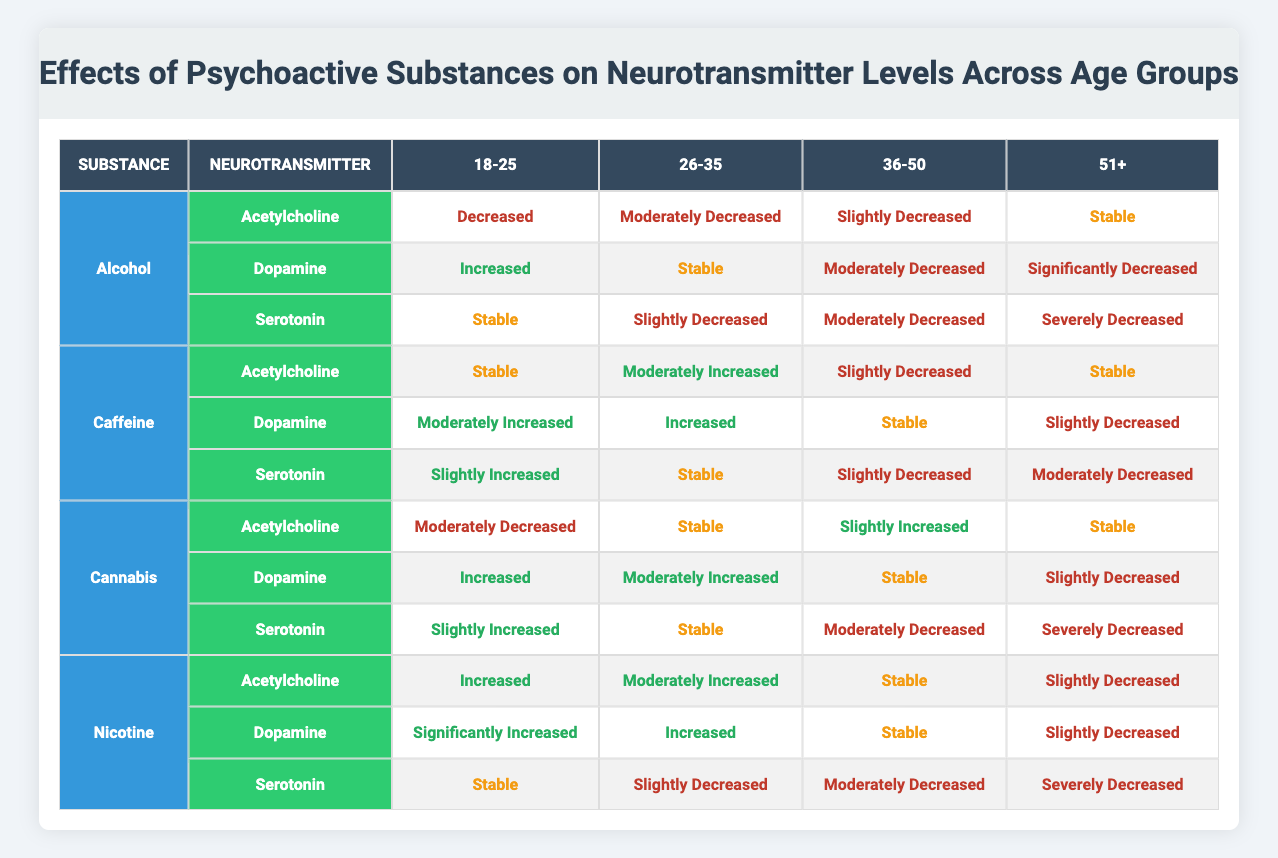What is the effect of Alcohol on Serotonin levels in the age group 36-50? According to the table, for Alcohol, the effect on Serotonin levels in the age group 36-50 is "Moderately Decreased." This can be found by looking at the row for Serotonin under Alcohol and then checking the value under the 36-50 age column.
Answer: Moderately Decreased Which psychoactive substance shows a "Stable" effect on Acetylcholine in individuals aged 51 and older? By scanning the table, the substances that show "Stable" effects on Acetylcholine for the age group 51+ are Alcohol and Caffeine. Both substances have the same effect listed under the specified age group.
Answer: Alcohol, Caffeine Do Caffeine's effects on Dopamine levels increase with age? Analyzing the table for Caffeine's effect on Dopamine levels across different age groups shows: Moderately Increased (18-25), Increased (26-35), Stable (36-50), and Slightly Decreased (51+). The trend does not indicate a consistent increase as age progresses, rather it fluctuates.
Answer: No What is the difference in effect on Serotonin between Cannabis and Alcohol for individuals aged 51 and older? First, find the Serotonin effect for Cannabis in the 51+ age group, which is "Severely Decreased." Then find the same for Alcohol, which is "Severely Decreased" as well. Since both effects are the same, there is no difference.
Answer: No difference Which neurotransmitter is significantly increased by Nicotine in the 18-25 age group? The table indicates that for Nicotine in the 18-25 age group, the effect on Dopamine levels is "Significantly Increased," while Acetylcholine is "Increased" and Serotonin is "Stable." Thus, the only neurotransmitter with a significant increase is Dopamine.
Answer: Dopamine What is the trend of Acetylcholine levels for Cannabis across the age groups? Reviewing the effects of Acetylcholine for Cannabis yields: Moderately Decreased (18-25), Stable (26-35), Slightly Increased (36-50), and Stable (51+). The trend indicates a decrease at young age, stability in middle age, and a slight increase in older age.
Answer: Decrease, Stability, Increase Which age group shows the most severe decrease in Serotonin levels when consuming Alcohol? Looking at the table under Serotonin for Alcohol, the effect is "Severely Decreased" for individuals aged 51 and older, which is the most severe decrease across all specified age groups.
Answer: 51+ How many neurotransmitters show an increased level in individuals aged 26-35 when consuming Caffeine? Under the effects table for Caffeine, Acetylcholine shows "Moderately Increased," Dopamine shows "Increased," and Serotonin shows "Stable." Therefore, two neurotransmitters (Acetylcholine and Dopamine) show increased levels while one remains stable. Thus, the total is two.
Answer: Two 